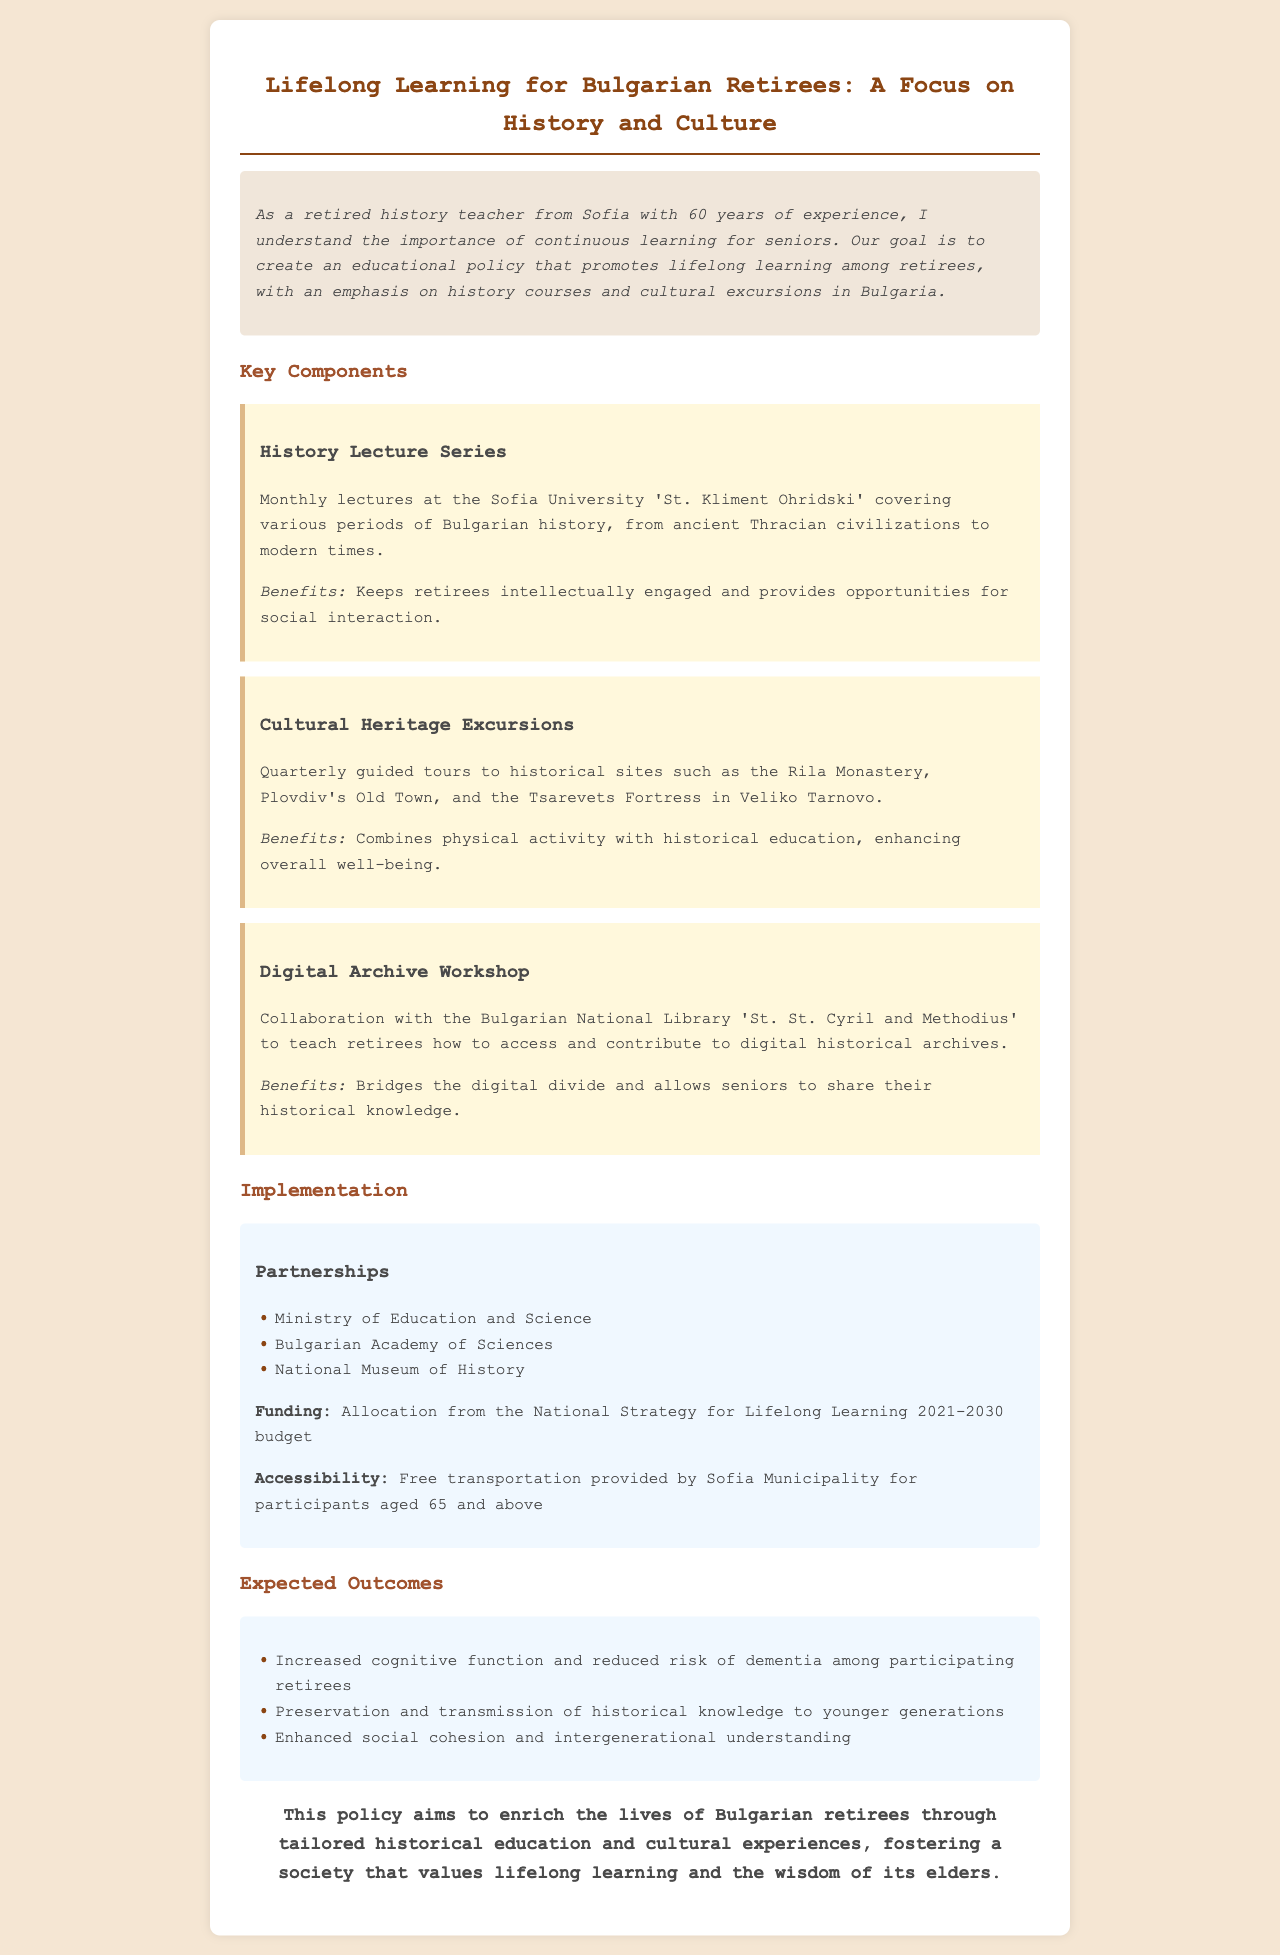what is the title of the document? The title is provided in the heading of the document.
Answer: Lifelong Learning for Bulgarian Retirees: A Focus on History and Culture how often are the history lectures held? The frequency of the lectures is explicitly mentioned in the document.
Answer: Monthly what organization collaborates for the digital archive workshop? The organization involved in the collaboration is specified in the document.
Answer: Bulgarian National Library 'St. St. Cyril and Methodius' what is one benefit of cultural heritage excursions? The document lists benefits of excursions under the appropriate section.
Answer: Enhancing overall well-being which ministry is a partner in this policy? The document lists the partners in the implementation section.
Answer: Ministry of Education and Science what year does the National Strategy for Lifelong Learning budget cover? The budget period is stated in the document.
Answer: 2021-2030 how many expected outcomes are listed in the document? The exact number of outcomes can be counted from the outcomes section.
Answer: Three what is provided for participants aged 65 and above? The document mentions specific support for this age group in the implementation section.
Answer: Free transportation what type of learning does this policy promote? The focus of the educational policy is highlighted in the introduction.
Answer: Lifelong learning 